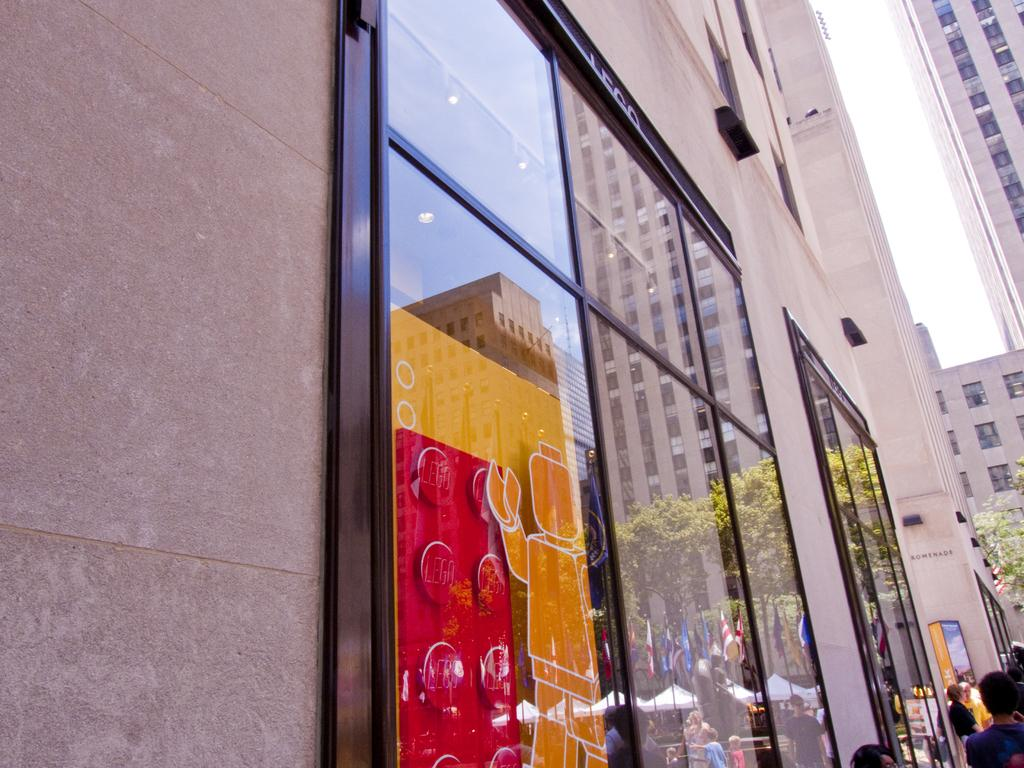What type of structures can be seen in the image? There are buildings in the image. What feature is present in the buildings? There are glass windows in the buildings. What type of natural elements are visible in the image? There are trees in the image. Are there any living beings in the image? Yes, there are people in the image. What else can be seen in the image besides the buildings, trees, and people? There are other objects in the image. What can be seen in the background of the image? The sky is visible in the background of the image. Where is the wall located in the image? There is a wall on the left side of the image. How does the deer interact with the wall in the image? There is no deer present in the image; it only features buildings, trees, people, and other objects. 